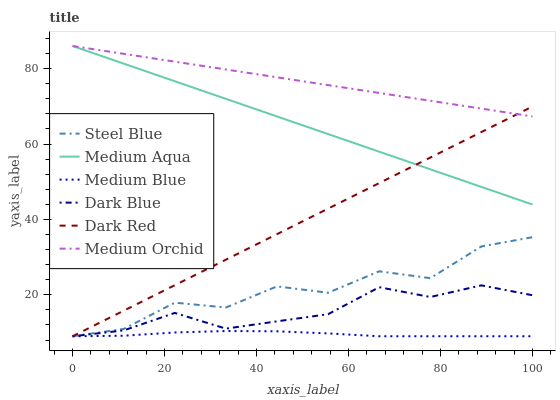Does Medium Blue have the minimum area under the curve?
Answer yes or no. Yes. Does Medium Orchid have the maximum area under the curve?
Answer yes or no. Yes. Does Medium Orchid have the minimum area under the curve?
Answer yes or no. No. Does Medium Blue have the maximum area under the curve?
Answer yes or no. No. Is Dark Red the smoothest?
Answer yes or no. Yes. Is Steel Blue the roughest?
Answer yes or no. Yes. Is Medium Orchid the smoothest?
Answer yes or no. No. Is Medium Orchid the roughest?
Answer yes or no. No. Does Dark Red have the lowest value?
Answer yes or no. Yes. Does Medium Orchid have the lowest value?
Answer yes or no. No. Does Medium Aqua have the highest value?
Answer yes or no. Yes. Does Medium Blue have the highest value?
Answer yes or no. No. Is Steel Blue less than Medium Aqua?
Answer yes or no. Yes. Is Medium Aqua greater than Medium Blue?
Answer yes or no. Yes. Does Medium Orchid intersect Medium Aqua?
Answer yes or no. Yes. Is Medium Orchid less than Medium Aqua?
Answer yes or no. No. Is Medium Orchid greater than Medium Aqua?
Answer yes or no. No. Does Steel Blue intersect Medium Aqua?
Answer yes or no. No. 